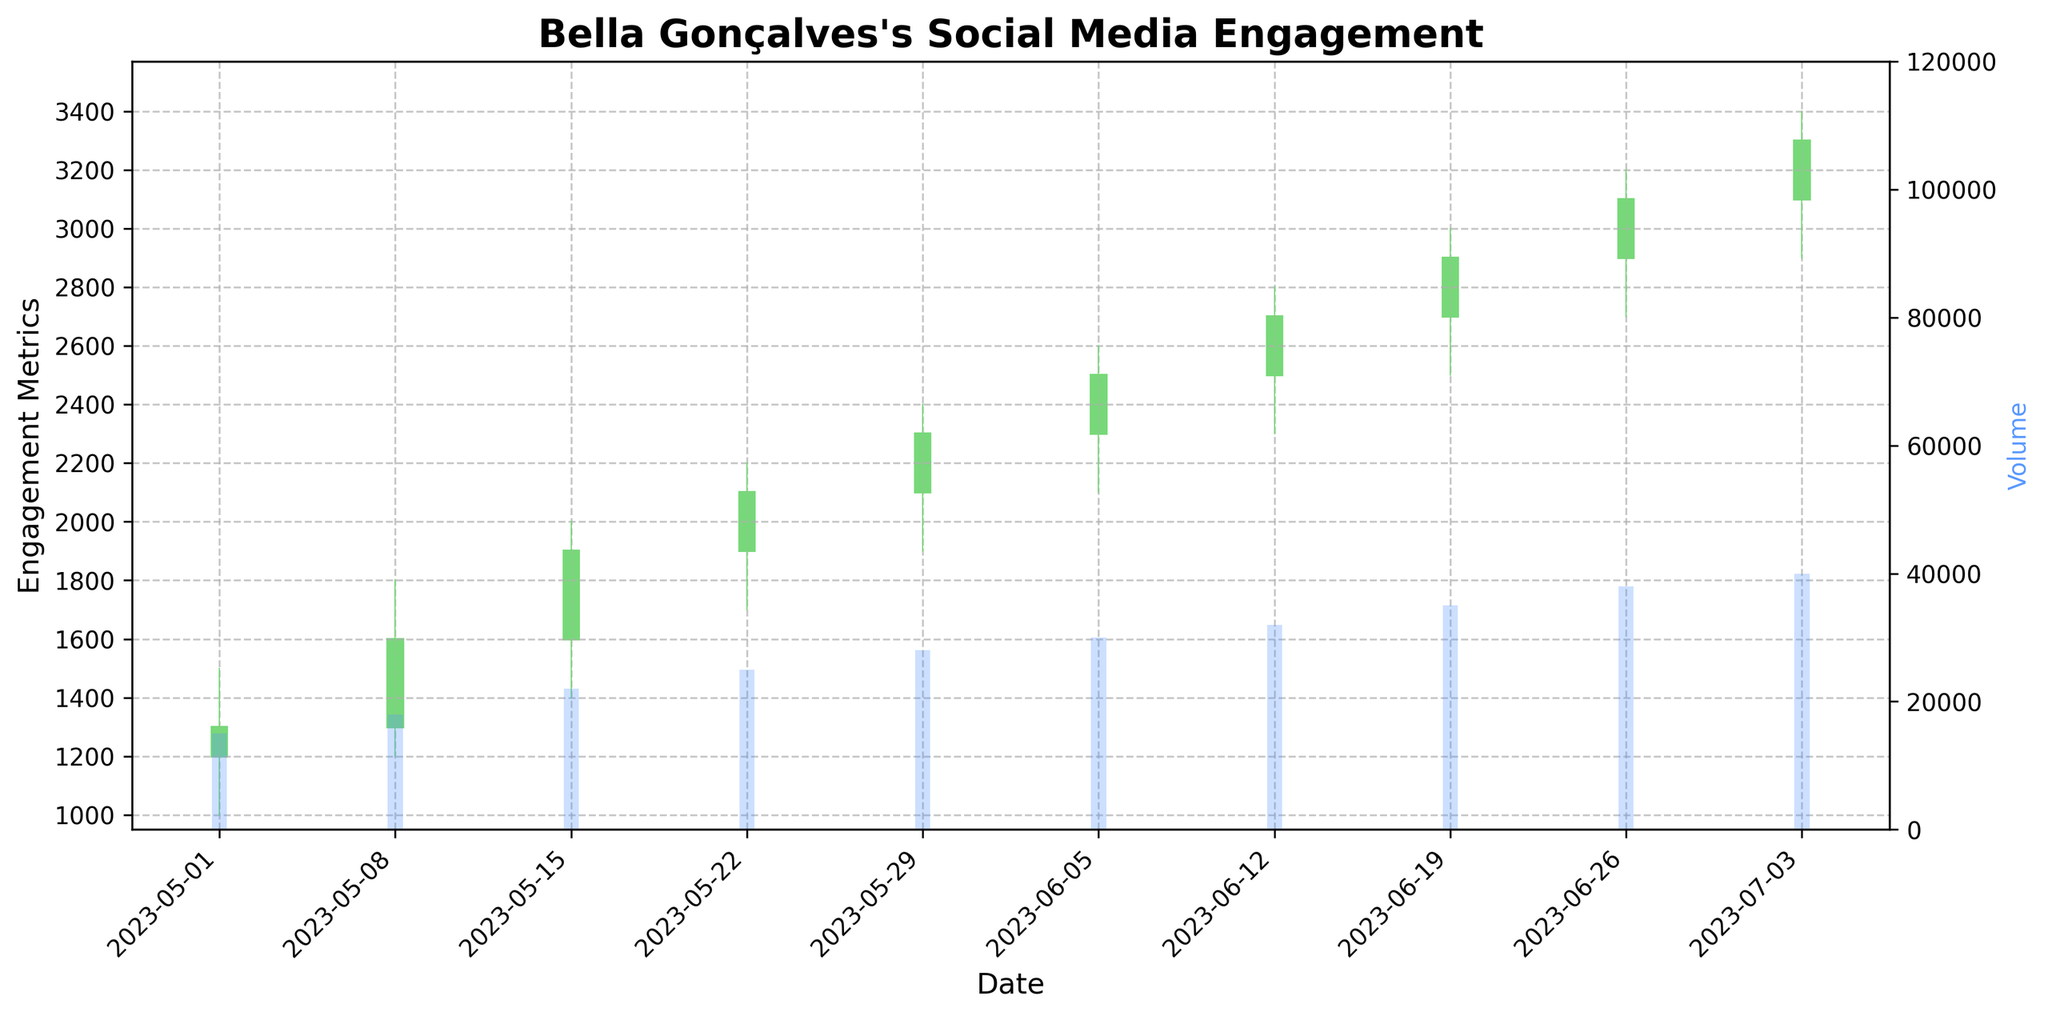What's the title of the figure? The title of the figure is located at the top and is usually in a larger and bold font. In this case, it reads "Bella Gonçalves's Social Media Engagement".
Answer: Bella Gonçalves's Social Media Engagement How does the overall engagement trend look from May to early July 2023? To analyze the trend, observe the closing values (the rightmost part of each candlestick) across the weekly data points. The closing values increase consistently from May to early July, indicating a strong upward trend.
Answer: Upward trend What was the closing value on 2023-06-05? Look at the candlestick for the week starting 2023-06-05; the closing value is represented by the top end of the solid part (body) of the candlestick.
Answer: 2500 In which week was the Volume the highest? Examine the height of the volume bars (colored rectangles) and identify the tallest one, which corresponds to the week starting 2023-07-03.
Answer: 2023-07-03 What is the minimum engagement metric plotted on the y-axis? The y-axis displays engagement metrics ranging from 0 upwards. The minimum value represented on the y-axis can be observed at the base, which is 1000.
Answer: 1000 How many weeks of data are presented in the figure? Count the number of candlesticks on the chart to get the total number of weeks of data presented. There are 10 candlesticks.
Answer: 10 weeks Which week experienced the highest engagement metric? How can you identify it? Check the highest values reached by the upper wicks of the candlesticks. The week starting 2023-07-03 shows the highest point of engagement, reaching 3400.
Answer: 2023-07-03 Did the engagement metric ever fall below its opening value in any given week? For a week where the engagement metrics fell below the opening value, the color of the candlestick would be red. However, all the candlesticks are green, indicating the engagement metric always rose above the opening value.
Answer: No What week had the smallest range between high and low engagement metrics, and what was that range? Calculate the range (High - Low) for each week by inspecting the top and the bottom of the wicks. The smallest range can be found for the week starting 2023-05-01 with a range of 500 (1500 - 1000).
Answer: 2023-05-01, 500 Compare the trading volume between the first and last week. How much did it increase? The volume in the first week (starting 2023-05-01) is 15000, and in the last week (starting 2023-07-03) is 40000. The increase is 40000 - 15000 = 25000.
Answer: 25000 